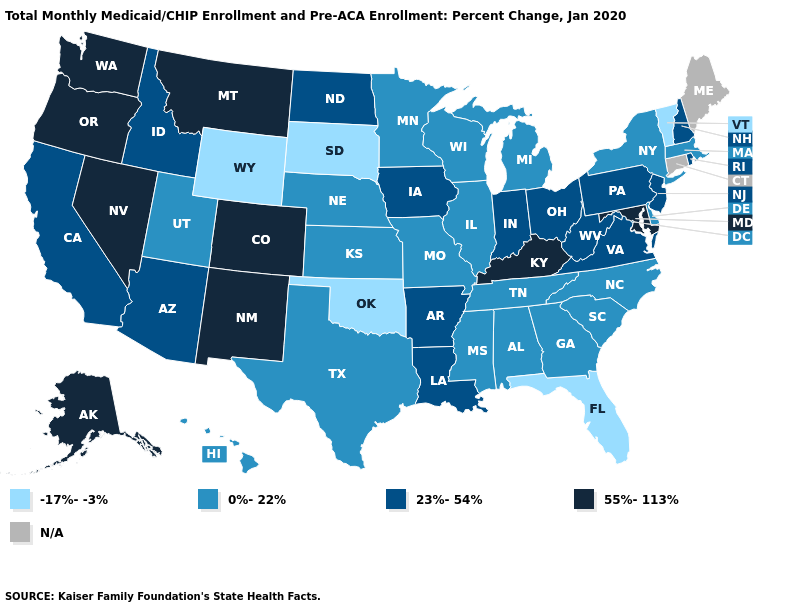Which states hav the highest value in the Northeast?
Answer briefly. New Hampshire, New Jersey, Pennsylvania, Rhode Island. What is the lowest value in the USA?
Give a very brief answer. -17%--3%. Which states hav the highest value in the South?
Quick response, please. Kentucky, Maryland. Which states have the lowest value in the MidWest?
Write a very short answer. South Dakota. Does Vermont have the lowest value in the Northeast?
Give a very brief answer. Yes. Which states hav the highest value in the West?
Answer briefly. Alaska, Colorado, Montana, Nevada, New Mexico, Oregon, Washington. Which states have the lowest value in the MidWest?
Give a very brief answer. South Dakota. What is the lowest value in the USA?
Keep it brief. -17%--3%. Which states have the highest value in the USA?
Keep it brief. Alaska, Colorado, Kentucky, Maryland, Montana, Nevada, New Mexico, Oregon, Washington. Name the states that have a value in the range N/A?
Short answer required. Connecticut, Maine. What is the lowest value in the USA?
Keep it brief. -17%--3%. How many symbols are there in the legend?
Give a very brief answer. 5. Does Wisconsin have the highest value in the MidWest?
Give a very brief answer. No. Does Montana have the highest value in the USA?
Answer briefly. Yes. 